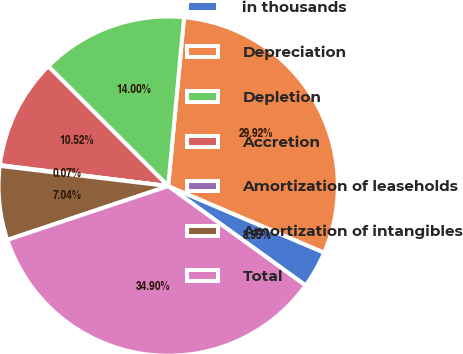Convert chart. <chart><loc_0><loc_0><loc_500><loc_500><pie_chart><fcel>in thousands<fcel>Depreciation<fcel>Depletion<fcel>Accretion<fcel>Amortization of leaseholds<fcel>Amortization of intangibles<fcel>Total<nl><fcel>3.55%<fcel>29.92%<fcel>14.0%<fcel>10.52%<fcel>0.07%<fcel>7.04%<fcel>34.9%<nl></chart> 